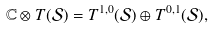<formula> <loc_0><loc_0><loc_500><loc_500>\mathbb { C } \otimes T ( \mathcal { S } ) = T ^ { 1 , 0 } ( \mathcal { S } ) \oplus T ^ { 0 , 1 } ( \mathcal { S } ) ,</formula> 